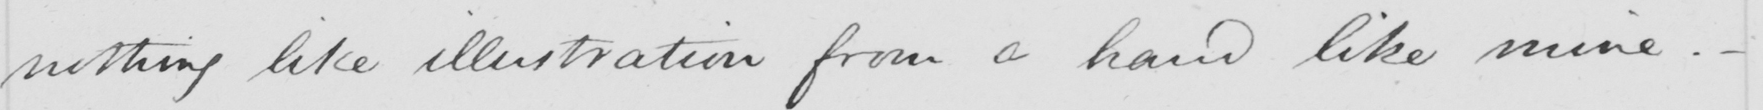What is written in this line of handwriting? nothing like illustration from a hand like mine . 